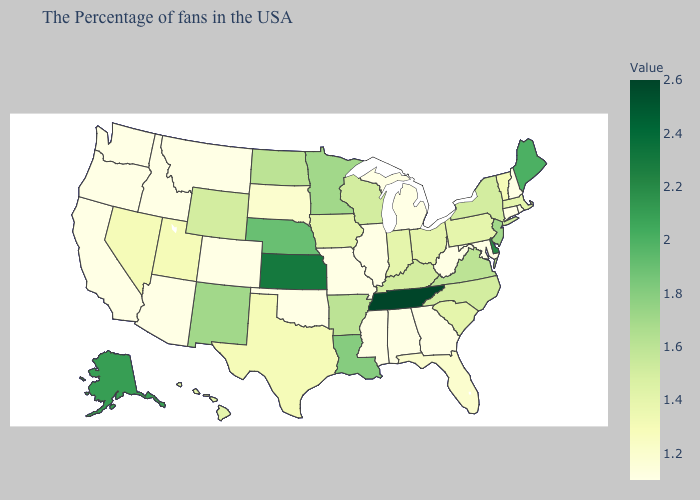Does Mississippi have the lowest value in the USA?
Be succinct. Yes. Does Nevada have the highest value in the West?
Write a very short answer. No. Does Maine have the highest value in the Northeast?
Write a very short answer. Yes. Is the legend a continuous bar?
Concise answer only. Yes. Is the legend a continuous bar?
Quick response, please. Yes. 